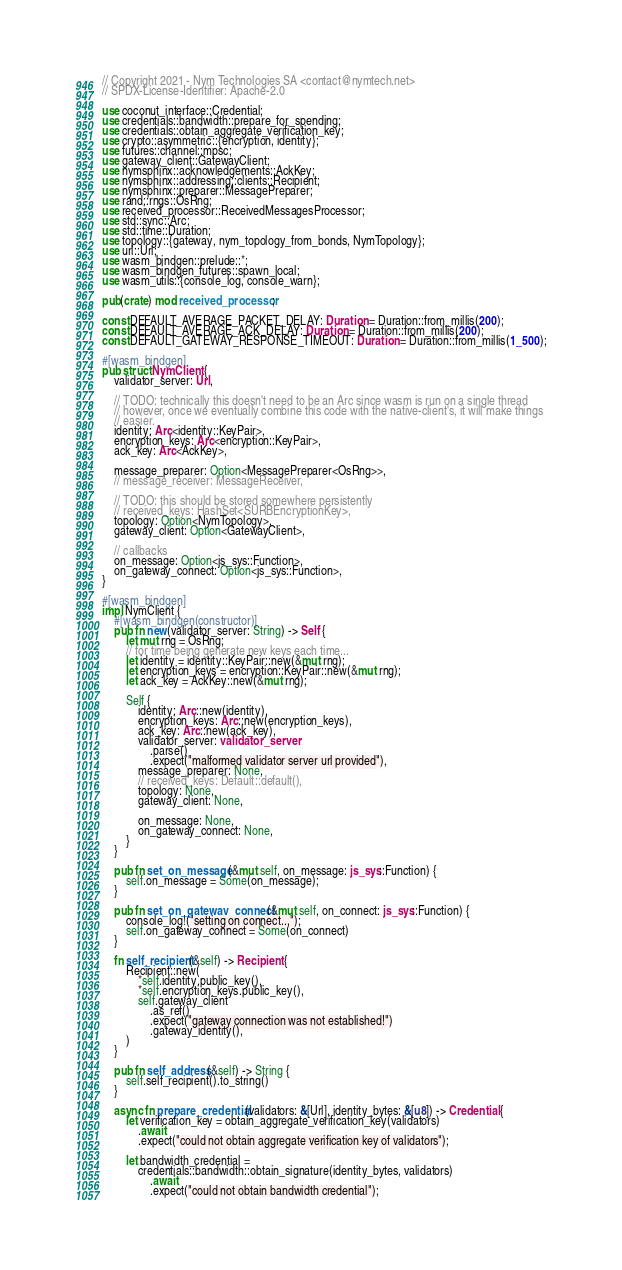Convert code to text. <code><loc_0><loc_0><loc_500><loc_500><_Rust_>// Copyright 2021 - Nym Technologies SA <contact@nymtech.net>
// SPDX-License-Identifier: Apache-2.0

use coconut_interface::Credential;
use credentials::bandwidth::prepare_for_spending;
use credentials::obtain_aggregate_verification_key;
use crypto::asymmetric::{encryption, identity};
use futures::channel::mpsc;
use gateway_client::GatewayClient;
use nymsphinx::acknowledgements::AckKey;
use nymsphinx::addressing::clients::Recipient;
use nymsphinx::preparer::MessagePreparer;
use rand::rngs::OsRng;
use received_processor::ReceivedMessagesProcessor;
use std::sync::Arc;
use std::time::Duration;
use topology::{gateway, nym_topology_from_bonds, NymTopology};
use url::Url;
use wasm_bindgen::prelude::*;
use wasm_bindgen_futures::spawn_local;
use wasm_utils::{console_log, console_warn};

pub(crate) mod received_processor;

const DEFAULT_AVERAGE_PACKET_DELAY: Duration = Duration::from_millis(200);
const DEFAULT_AVERAGE_ACK_DELAY: Duration = Duration::from_millis(200);
const DEFAULT_GATEWAY_RESPONSE_TIMEOUT: Duration = Duration::from_millis(1_500);

#[wasm_bindgen]
pub struct NymClient {
    validator_server: Url,

    // TODO: technically this doesn't need to be an Arc since wasm is run on a single thread
    // however, once we eventually combine this code with the native-client's, it will make things
    // easier.
    identity: Arc<identity::KeyPair>,
    encryption_keys: Arc<encryption::KeyPair>,
    ack_key: Arc<AckKey>,

    message_preparer: Option<MessagePreparer<OsRng>>,
    // message_receiver: MessageReceiver,

    // TODO: this should be stored somewhere persistently
    // received_keys: HashSet<SURBEncryptionKey>,
    topology: Option<NymTopology>,
    gateway_client: Option<GatewayClient>,

    // callbacks
    on_message: Option<js_sys::Function>,
    on_gateway_connect: Option<js_sys::Function>,
}

#[wasm_bindgen]
impl NymClient {
    #[wasm_bindgen(constructor)]
    pub fn new(validator_server: String) -> Self {
        let mut rng = OsRng;
        // for time being generate new keys each time...
        let identity = identity::KeyPair::new(&mut rng);
        let encryption_keys = encryption::KeyPair::new(&mut rng);
        let ack_key = AckKey::new(&mut rng);

        Self {
            identity: Arc::new(identity),
            encryption_keys: Arc::new(encryption_keys),
            ack_key: Arc::new(ack_key),
            validator_server: validator_server
                .parse()
                .expect("malformed validator server url provided"),
            message_preparer: None,
            // received_keys: Default::default(),
            topology: None,
            gateway_client: None,

            on_message: None,
            on_gateway_connect: None,
        }
    }

    pub fn set_on_message(&mut self, on_message: js_sys::Function) {
        self.on_message = Some(on_message);
    }

    pub fn set_on_gateway_connect(&mut self, on_connect: js_sys::Function) {
        console_log!("setting on connect...");
        self.on_gateway_connect = Some(on_connect)
    }

    fn self_recipient(&self) -> Recipient {
        Recipient::new(
            *self.identity.public_key(),
            *self.encryption_keys.public_key(),
            self.gateway_client
                .as_ref()
                .expect("gateway connection was not established!")
                .gateway_identity(),
        )
    }

    pub fn self_address(&self) -> String {
        self.self_recipient().to_string()
    }

    async fn prepare_credential(validators: &[Url], identity_bytes: &[u8]) -> Credential {
        let verification_key = obtain_aggregate_verification_key(validators)
            .await
            .expect("could not obtain aggregate verification key of validators");

        let bandwidth_credential =
            credentials::bandwidth::obtain_signature(identity_bytes, validators)
                .await
                .expect("could not obtain bandwidth credential");</code> 